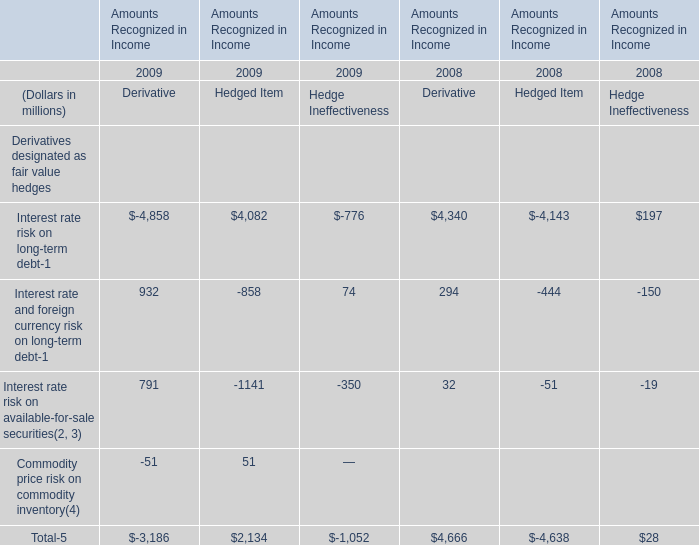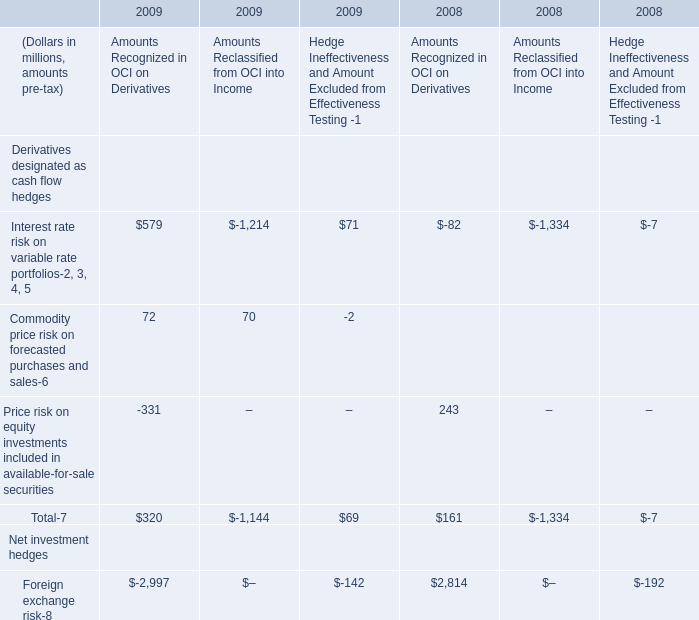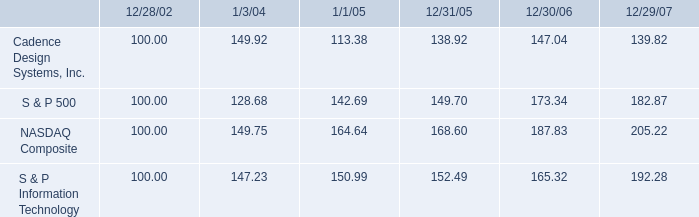What's the total amount of Interest rate risk on long-term debt in 2009? (in million) 
Computations: ((932 - 858) + 74)
Answer: 148.0. 